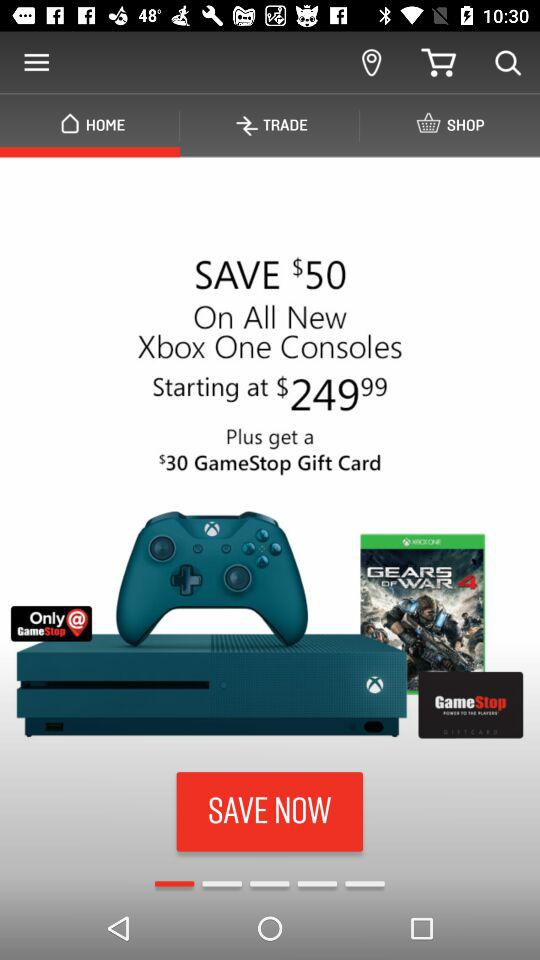What is the starting price of "Xbox One"? The starting price is $249.99. 